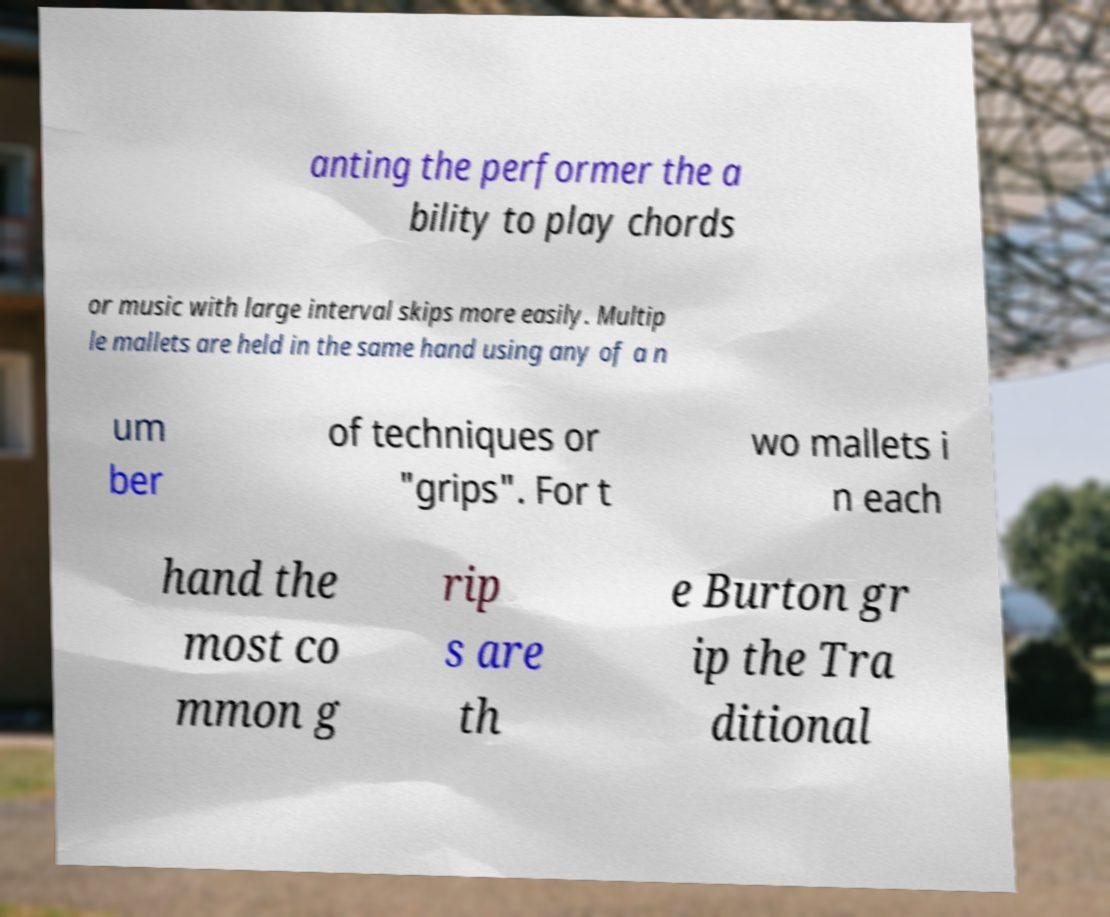Could you extract and type out the text from this image? anting the performer the a bility to play chords or music with large interval skips more easily. Multip le mallets are held in the same hand using any of a n um ber of techniques or "grips". For t wo mallets i n each hand the most co mmon g rip s are th e Burton gr ip the Tra ditional 